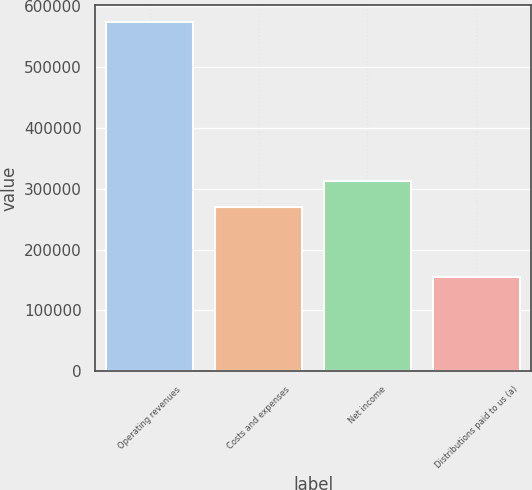Convert chart to OTSL. <chart><loc_0><loc_0><loc_500><loc_500><bar_chart><fcel>Operating revenues<fcel>Costs and expenses<fcel>Net income<fcel>Distributions paid to us (a)<nl><fcel>573197<fcel>269858<fcel>311604<fcel>155741<nl></chart> 